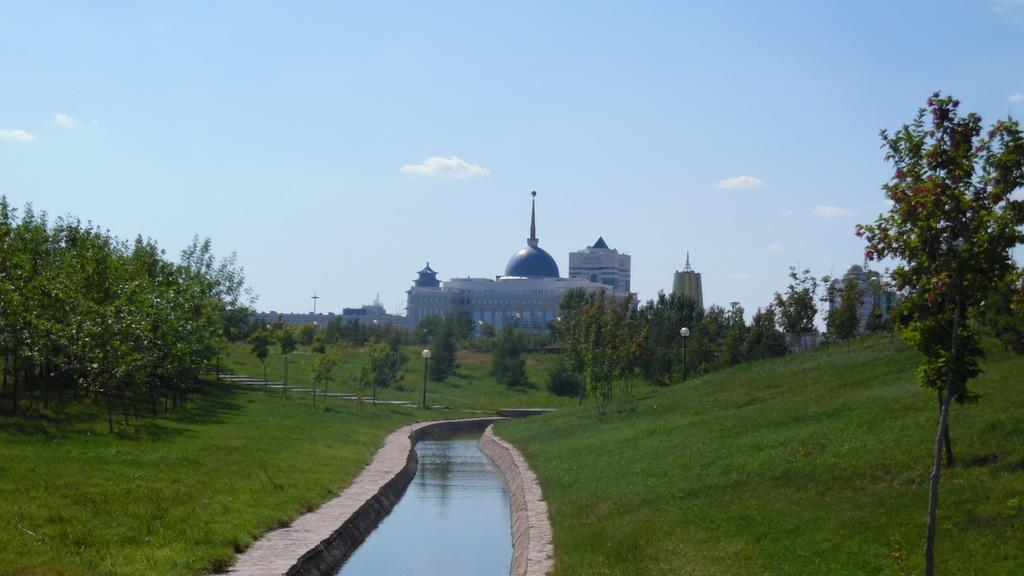What type of vegetation can be seen in the image? There are trees and grass in the image. What natural element is visible in the image? Water is visible in the image. What type of artificial lighting is present in the image? Street lights are present in the image. What structures can be seen in the background of the image? There are buildings in the background of the image. What part of the natural environment is visible in the image? The sky is visible in the image. What atmospheric feature can be seen in the sky? Clouds are present in the sky. What type of company is conducting a test in the image? There is no company or test present in the image. 